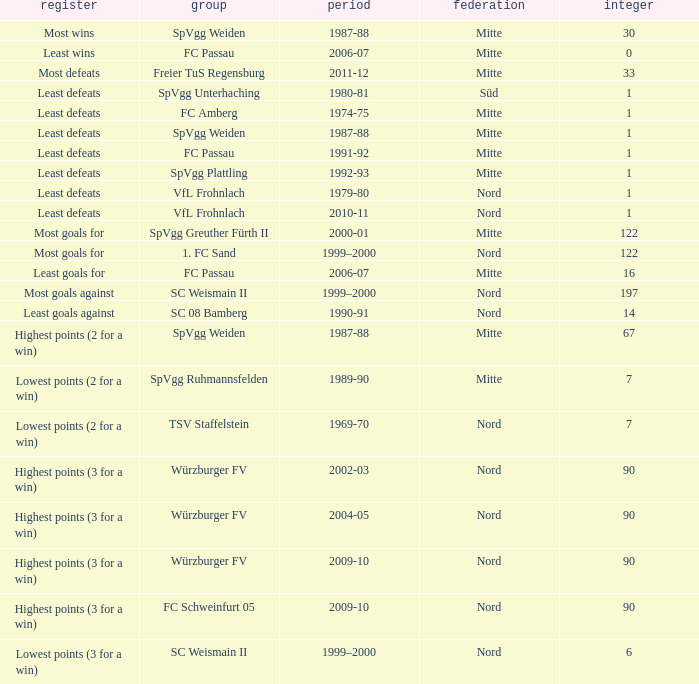What season has a number less than 90, Mitte as the league and spvgg ruhmannsfelden as the team? 1989-90. 